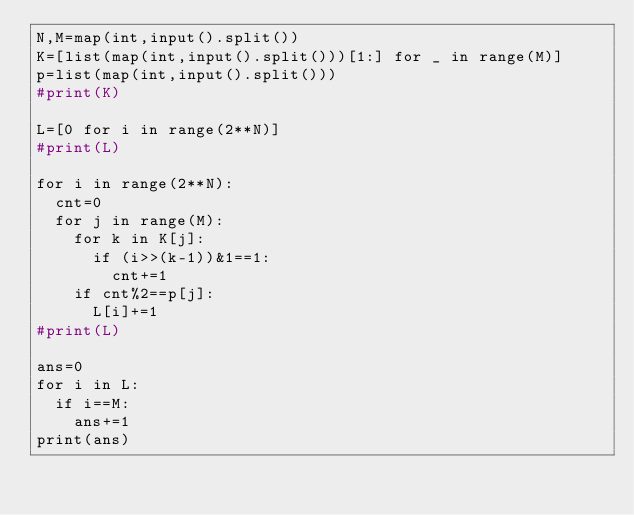Convert code to text. <code><loc_0><loc_0><loc_500><loc_500><_Python_>N,M=map(int,input().split())
K=[list(map(int,input().split()))[1:] for _ in range(M)]
p=list(map(int,input().split()))
#print(K)

L=[0 for i in range(2**N)]
#print(L)

for i in range(2**N):
  cnt=0
  for j in range(M):
    for k in K[j]:
      if (i>>(k-1))&1==1:
        cnt+=1
    if cnt%2==p[j]:
      L[i]+=1
#print(L)

ans=0
for i in L:
  if i==M:
    ans+=1
print(ans)</code> 